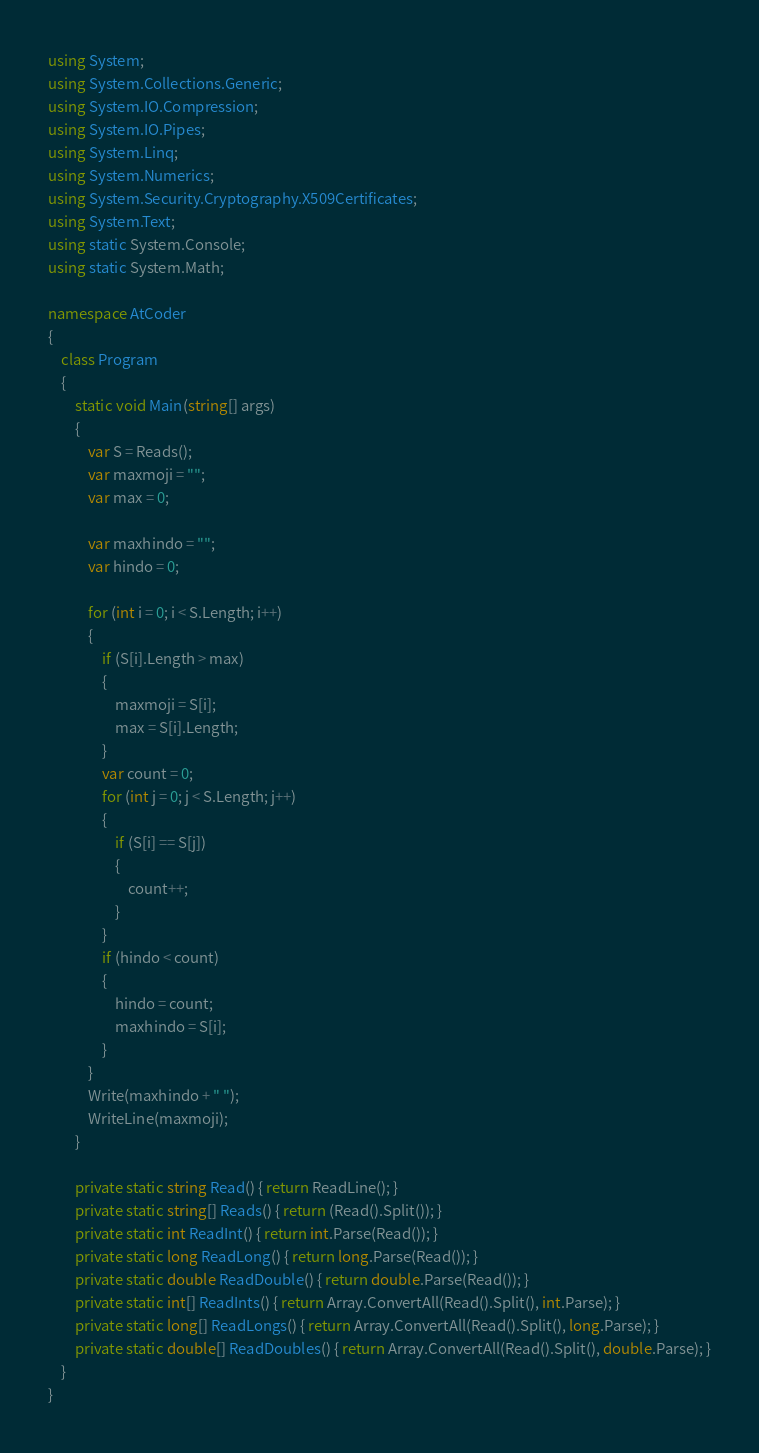<code> <loc_0><loc_0><loc_500><loc_500><_C#_>using System;
using System.Collections.Generic;
using System.IO.Compression;
using System.IO.Pipes;
using System.Linq;
using System.Numerics;
using System.Security.Cryptography.X509Certificates;
using System.Text;
using static System.Console;
using static System.Math;

namespace AtCoder
{
    class Program
    {
        static void Main(string[] args)
        {
            var S = Reads();
            var maxmoji = "";
            var max = 0;

            var maxhindo = "";
            var hindo = 0;

            for (int i = 0; i < S.Length; i++)
            {
                if (S[i].Length > max)
                {
                    maxmoji = S[i];
                    max = S[i].Length;
                }
                var count = 0;
                for (int j = 0; j < S.Length; j++)
                {
                    if (S[i] == S[j])
                    {
                        count++;
                    }
                }
                if (hindo < count)
                {
                    hindo = count;
                    maxhindo = S[i];
                }
            }
            Write(maxhindo + " ");
            WriteLine(maxmoji);
        }

        private static string Read() { return ReadLine(); }
        private static string[] Reads() { return (Read().Split()); }
        private static int ReadInt() { return int.Parse(Read()); }
        private static long ReadLong() { return long.Parse(Read()); }
        private static double ReadDouble() { return double.Parse(Read()); }
        private static int[] ReadInts() { return Array.ConvertAll(Read().Split(), int.Parse); }
        private static long[] ReadLongs() { return Array.ConvertAll(Read().Split(), long.Parse); }
        private static double[] ReadDoubles() { return Array.ConvertAll(Read().Split(), double.Parse); }
    }
}

</code> 